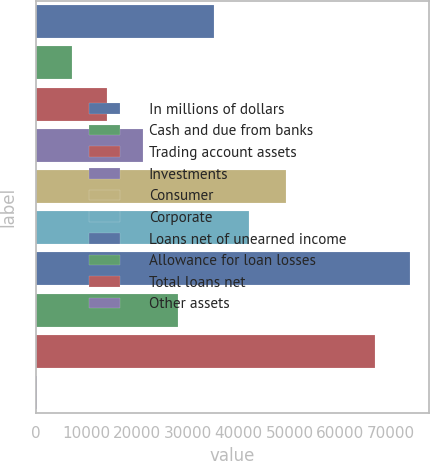Convert chart. <chart><loc_0><loc_0><loc_500><loc_500><bar_chart><fcel>In millions of dollars<fcel>Cash and due from banks<fcel>Trading account assets<fcel>Investments<fcel>Consumer<fcel>Corporate<fcel>Loans net of unearned income<fcel>Allowance for loan losses<fcel>Total loans net<fcel>Other assets<nl><fcel>35047.5<fcel>7130.3<fcel>14109.6<fcel>21088.9<fcel>49403<fcel>42026.8<fcel>73789.3<fcel>28068.2<fcel>66810<fcel>151<nl></chart> 